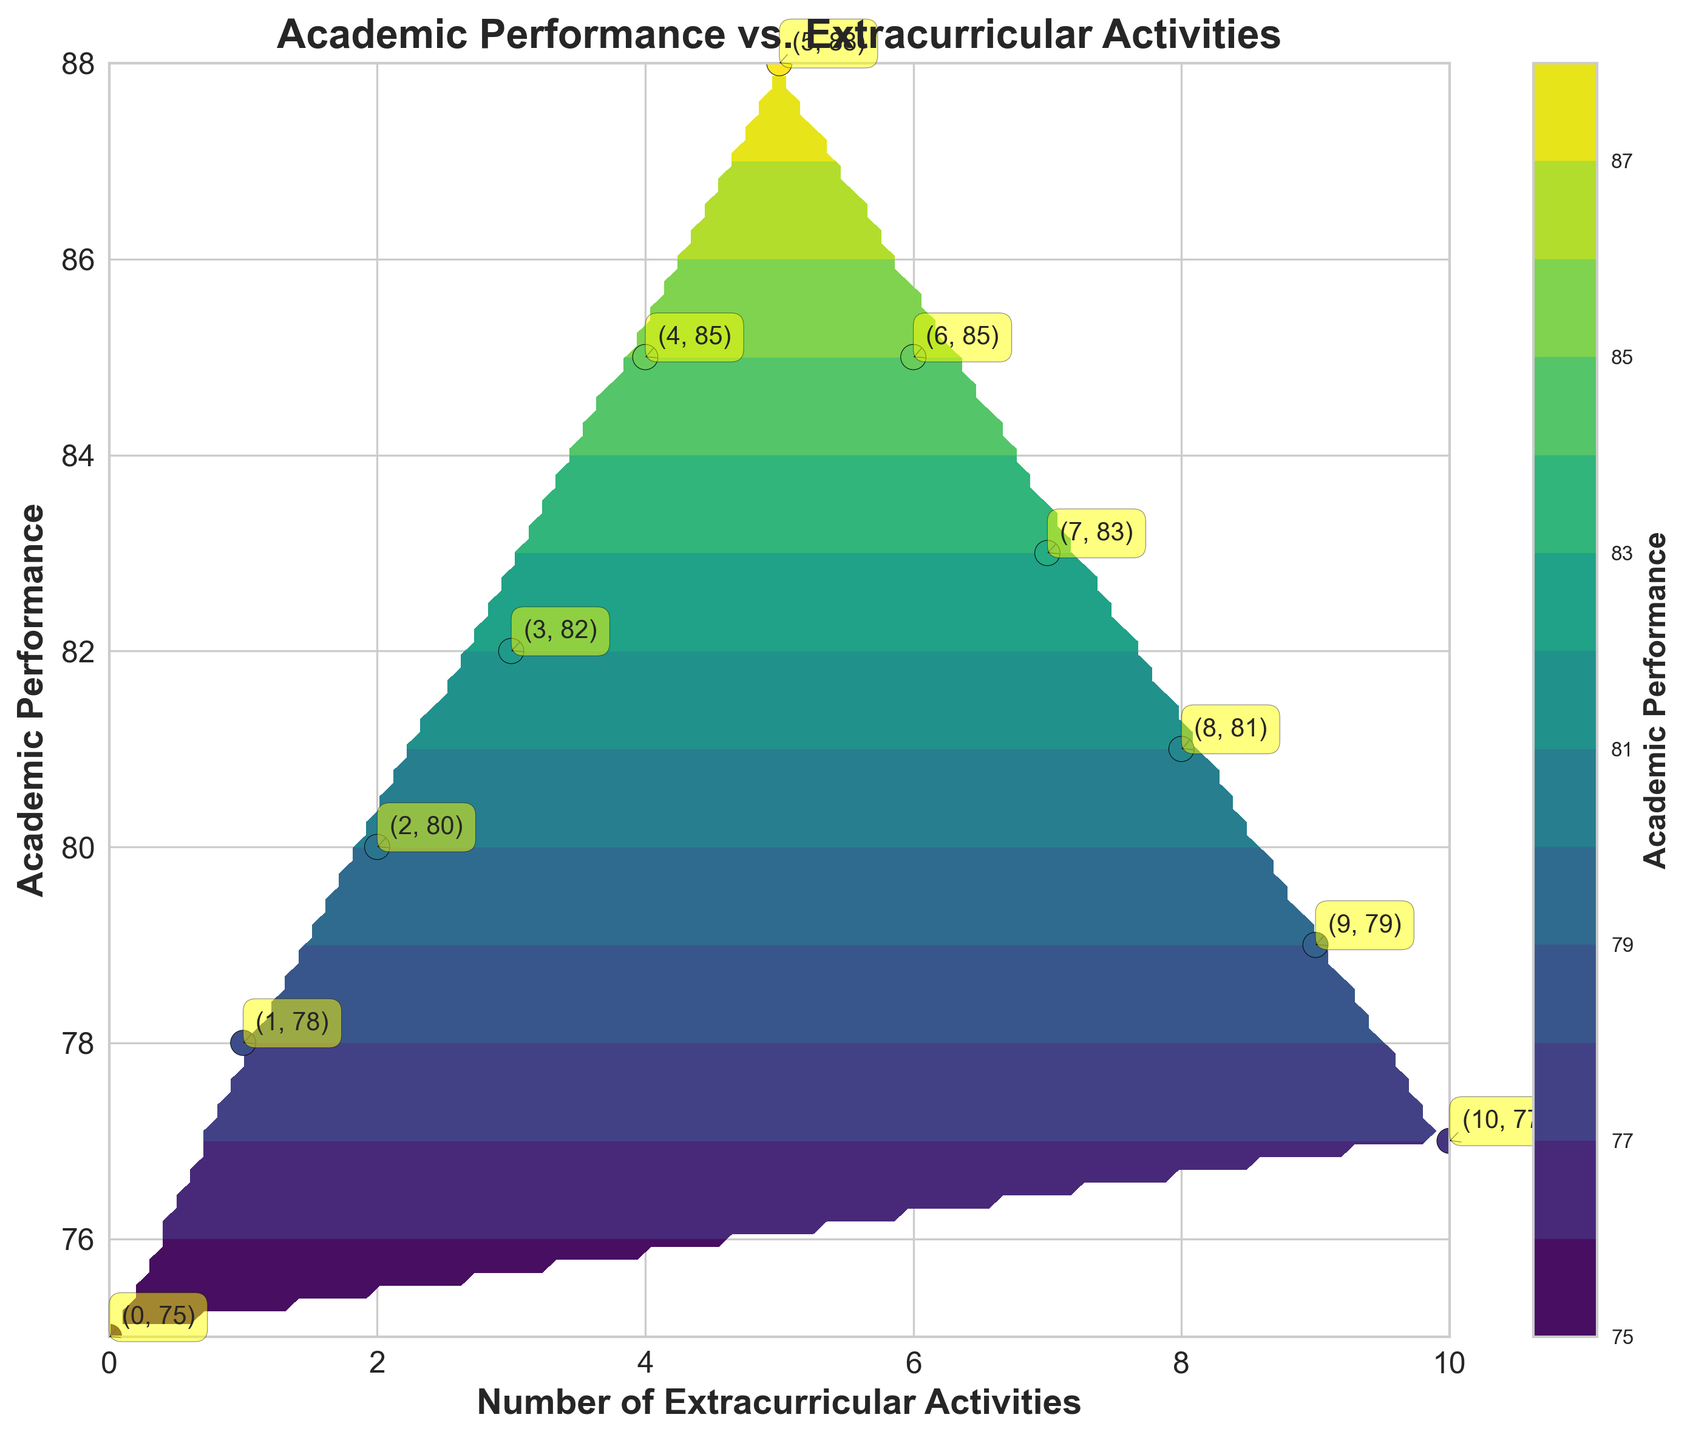What's the title of the figure? The title of the figure is always found at the top and it summarizes the main point of the chart. Here, it reads "Academic Performance vs. Extracurricular Activities".
Answer: Academic Performance vs. Extracurricular Activities What are the labels of the x-axis and y-axis? The labels of the axes describe what each axis represents. For this plot, the x-axis label is "Number of Extracurricular Activities" and the y-axis label is "Academic Performance".
Answer: Number of Extracurricular Activities, Academic Performance How many original data points are plotted on the figure? Original data points are represented by small circles with labels. Counting these, we see there are 11 data points.
Answer: 11 What academic performance corresponds to having 5 extracurricular activities? Locate the label on the plot that corresponds to "5" on the x-axis. The label indicates the academic performance is 88 when there are 5 extracurricular activities.
Answer: 88 Which number of extracurricular activities is associated with the highest academic performance? Looking at the data points, the highest academic performance value is 88, which corresponds to 5 extracurricular activities.
Answer: 5 At what point does the academic performance begin to decline with increasing extracurricular activities? The plot shows that after peaking at 5 activities (88), academic performance begins to decline. Therefore, it starts to decline from the 6th extracurricular activity, where the academic performance drops to 85.
Answer: 6 What is the range of academic performance values shown in the figure? The range is the difference between the maximum and minimum values. The minimum value is 75 and the maximum is 88, giving a range of 88 - 75 = 13.
Answer: 13 What is the average academic performance for children with 0 to 10 extracurricular activities? To find the average, sum all the academic performance values and divide by the number of data points. The sum is 75+78+80+82+85+88+85+83+81+79+77 = 893, and the number of data points is 11. So, the average is 893/11 ≈ 81.18.
Answer: 81.18 Which academic performances are higher than 80 for the given data? Academic performances higher than 80 are visible from the figure. They are 82, 85, 88, 85, 83, and 81.
Answer: 82, 85, 88, 85, 83, 81 Describe the overall trend observed in the figure regarding academic performance and extracurricular activities. The general trend shows that academic performance improves with an increasing number of extracurricular activities, peaking at 5 activities, beyond which it starts to decline. This can be observed by the rise and fall of the contour and scatter plot points.
Answer: Increases, peaks, then declines 